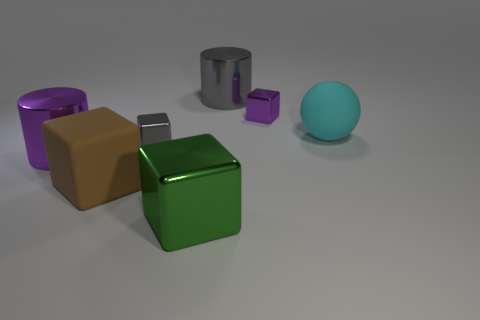What can you infer about the lighting in this scene? The shadows cast by the objects suggest that the lighting in this scene is coming from the upper left, casting a soft, diffuse light across the scene. The slight reflections on the surfaces of the objects, particularly on the silver cube and the green cube, indicate the presence of a strong yet not harsh light source. 